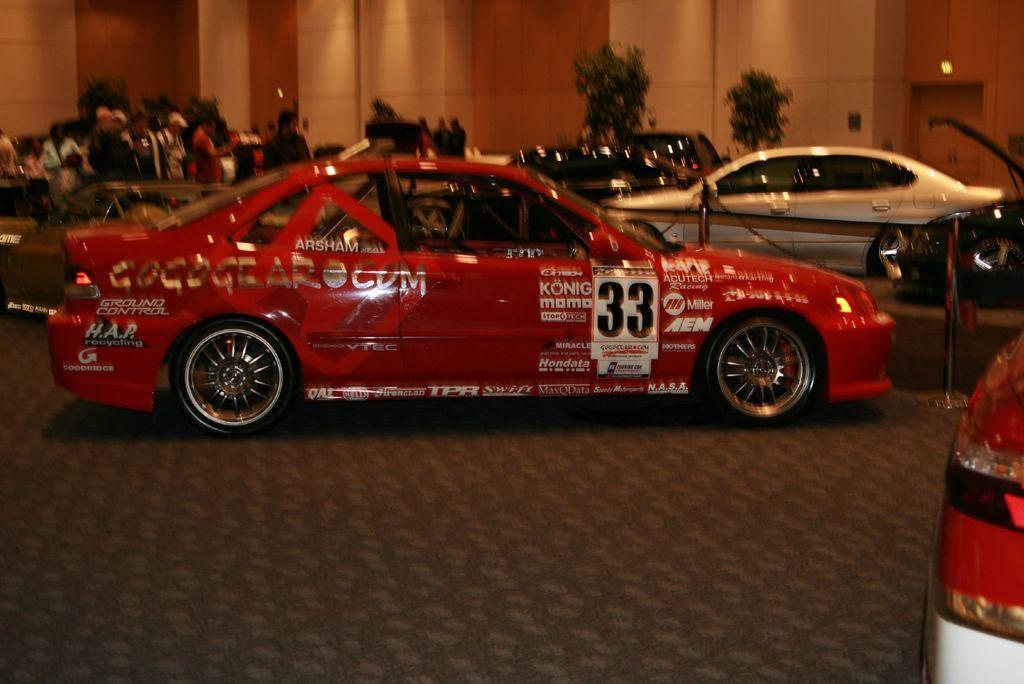Could you give a brief overview of what you see in this image? In this picture we can see few cars and metal rods, in the background we can find group of people, few trees and lights. 